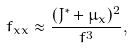<formula> <loc_0><loc_0><loc_500><loc_500>f _ { x x } \approx \frac { ( J ^ { * } + \mu _ { x } ) ^ { 2 } } { f ^ { 3 } } ,</formula> 